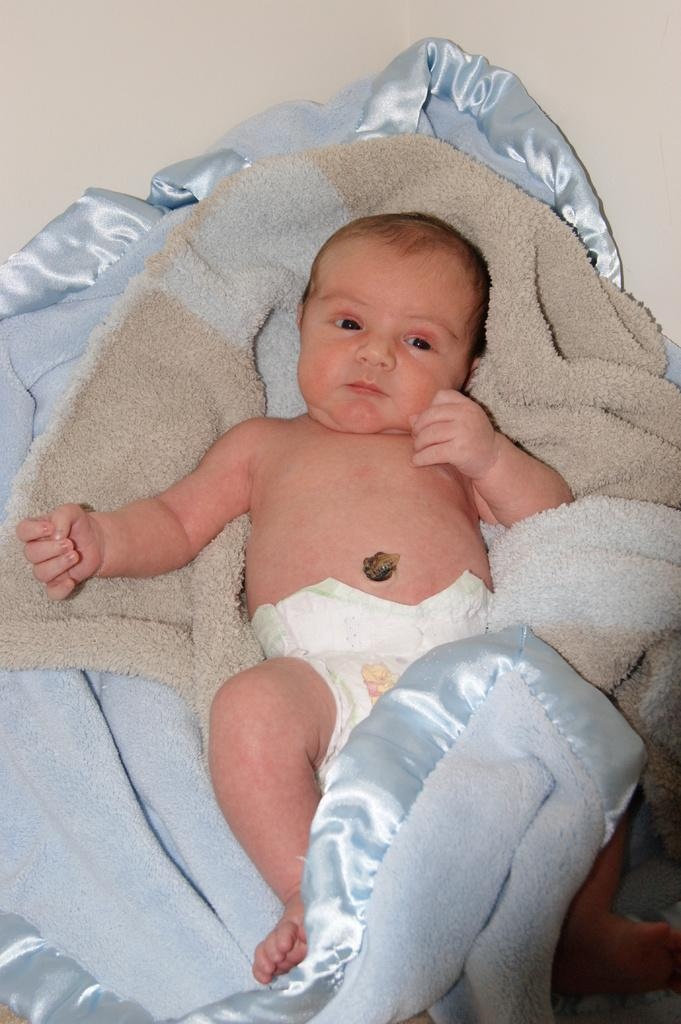What is the main subject of the image? There is a baby in the image. What is the baby laying on? The baby is laying on a bed sheet. What can be seen in the background of the image? There is a wall visible in the image. What type of snail can be seen crawling on the wall in the image? There is no snail present in the image; only the baby, bed sheet, and wall are visible. 